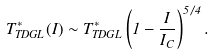<formula> <loc_0><loc_0><loc_500><loc_500>T ^ { * } _ { T D G L } ( I ) \sim T _ { T D G L } ^ { * } \left ( 1 - \frac { I } { I _ { C } } \right ) ^ { 5 / 4 } .</formula> 